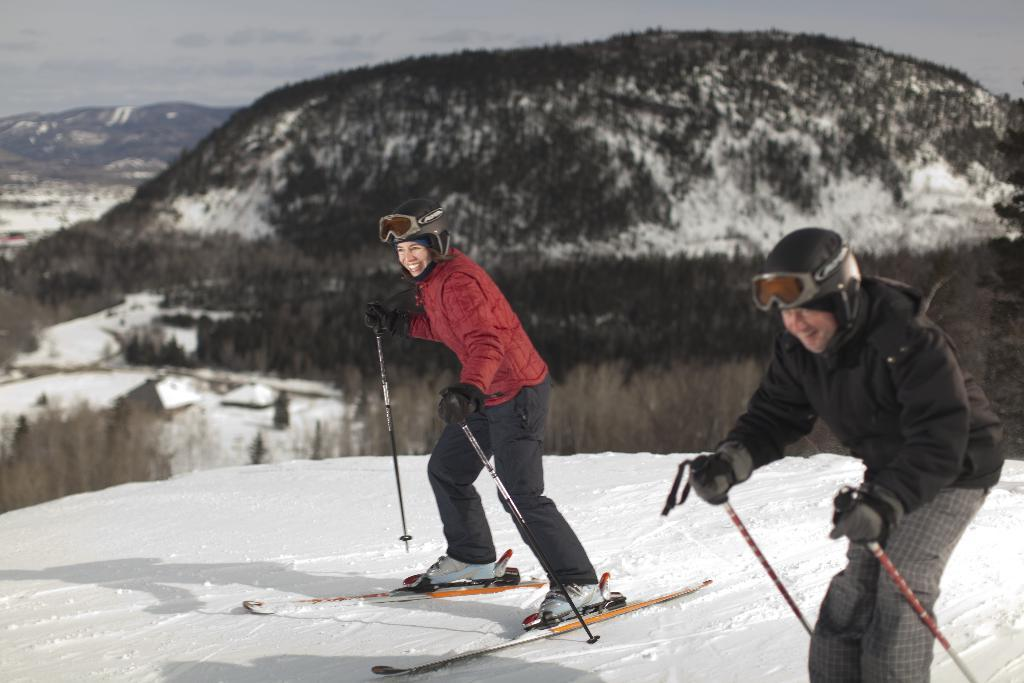How many people are in the image? There are two people in the image, a man and a woman. What are they doing in the image? Both the man and the woman are skiing on the snow. What are they holding while skiing? They are holding skiing sticks. What can be seen in the background of the image? There is a group of trees and ice hills visible in the background. What is the condition of the sky in the image? The sky is cloudy in the image. What type of plants can be seen growing on the skiing sticks? There are no plants visible on the skiing sticks in the image. What is the cause of the ice hills in the background? The image does not provide information about the cause of the ice hills in the background. 